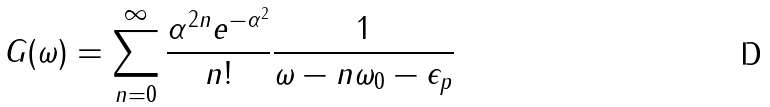<formula> <loc_0><loc_0><loc_500><loc_500>G ( \omega ) = \sum _ { n = 0 } ^ { \infty } \frac { \alpha ^ { 2 n } e ^ { - \alpha ^ { 2 } } } { n ! } \frac { 1 } { \omega - n \omega _ { 0 } - \epsilon _ { p } }</formula> 